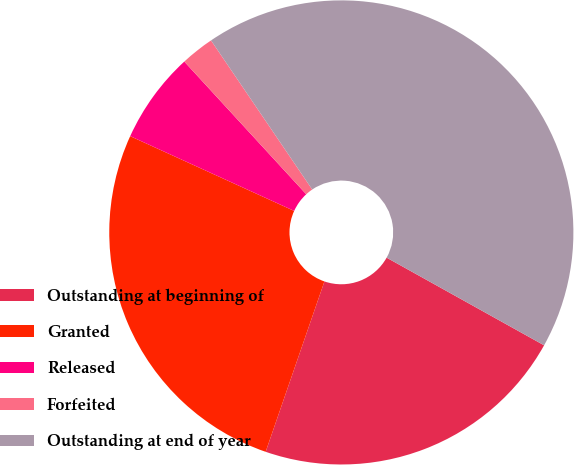Convert chart to OTSL. <chart><loc_0><loc_0><loc_500><loc_500><pie_chart><fcel>Outstanding at beginning of<fcel>Granted<fcel>Released<fcel>Forfeited<fcel>Outstanding at end of year<nl><fcel>22.2%<fcel>26.52%<fcel>6.36%<fcel>2.34%<fcel>42.57%<nl></chart> 